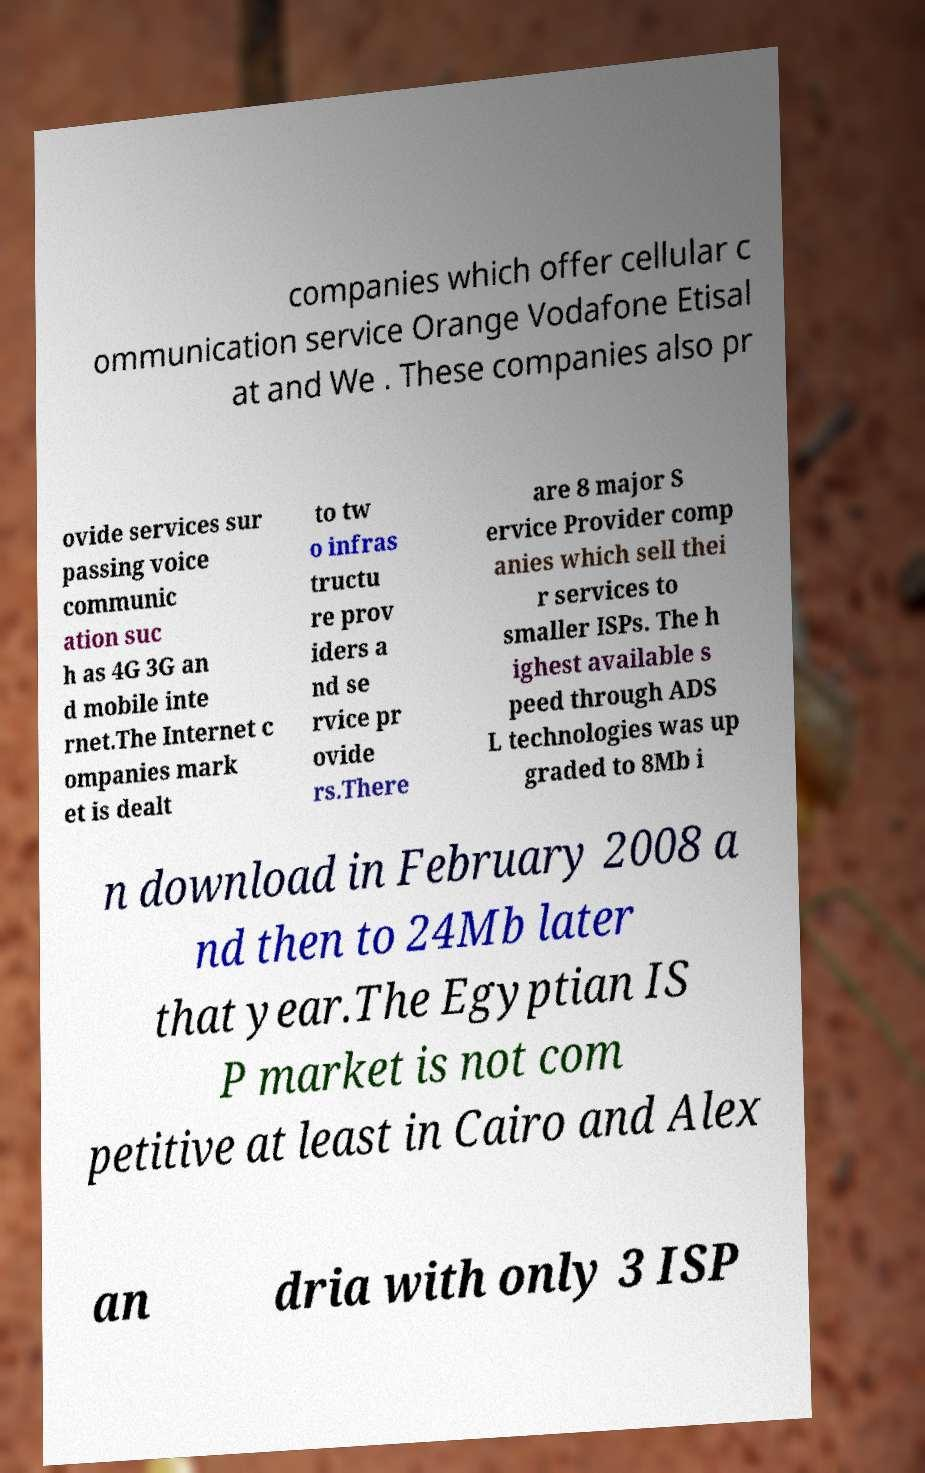There's text embedded in this image that I need extracted. Can you transcribe it verbatim? companies which offer cellular c ommunication service Orange Vodafone Etisal at and We . These companies also pr ovide services sur passing voice communic ation suc h as 4G 3G an d mobile inte rnet.The Internet c ompanies mark et is dealt to tw o infras tructu re prov iders a nd se rvice pr ovide rs.There are 8 major S ervice Provider comp anies which sell thei r services to smaller ISPs. The h ighest available s peed through ADS L technologies was up graded to 8Mb i n download in February 2008 a nd then to 24Mb later that year.The Egyptian IS P market is not com petitive at least in Cairo and Alex an dria with only 3 ISP 